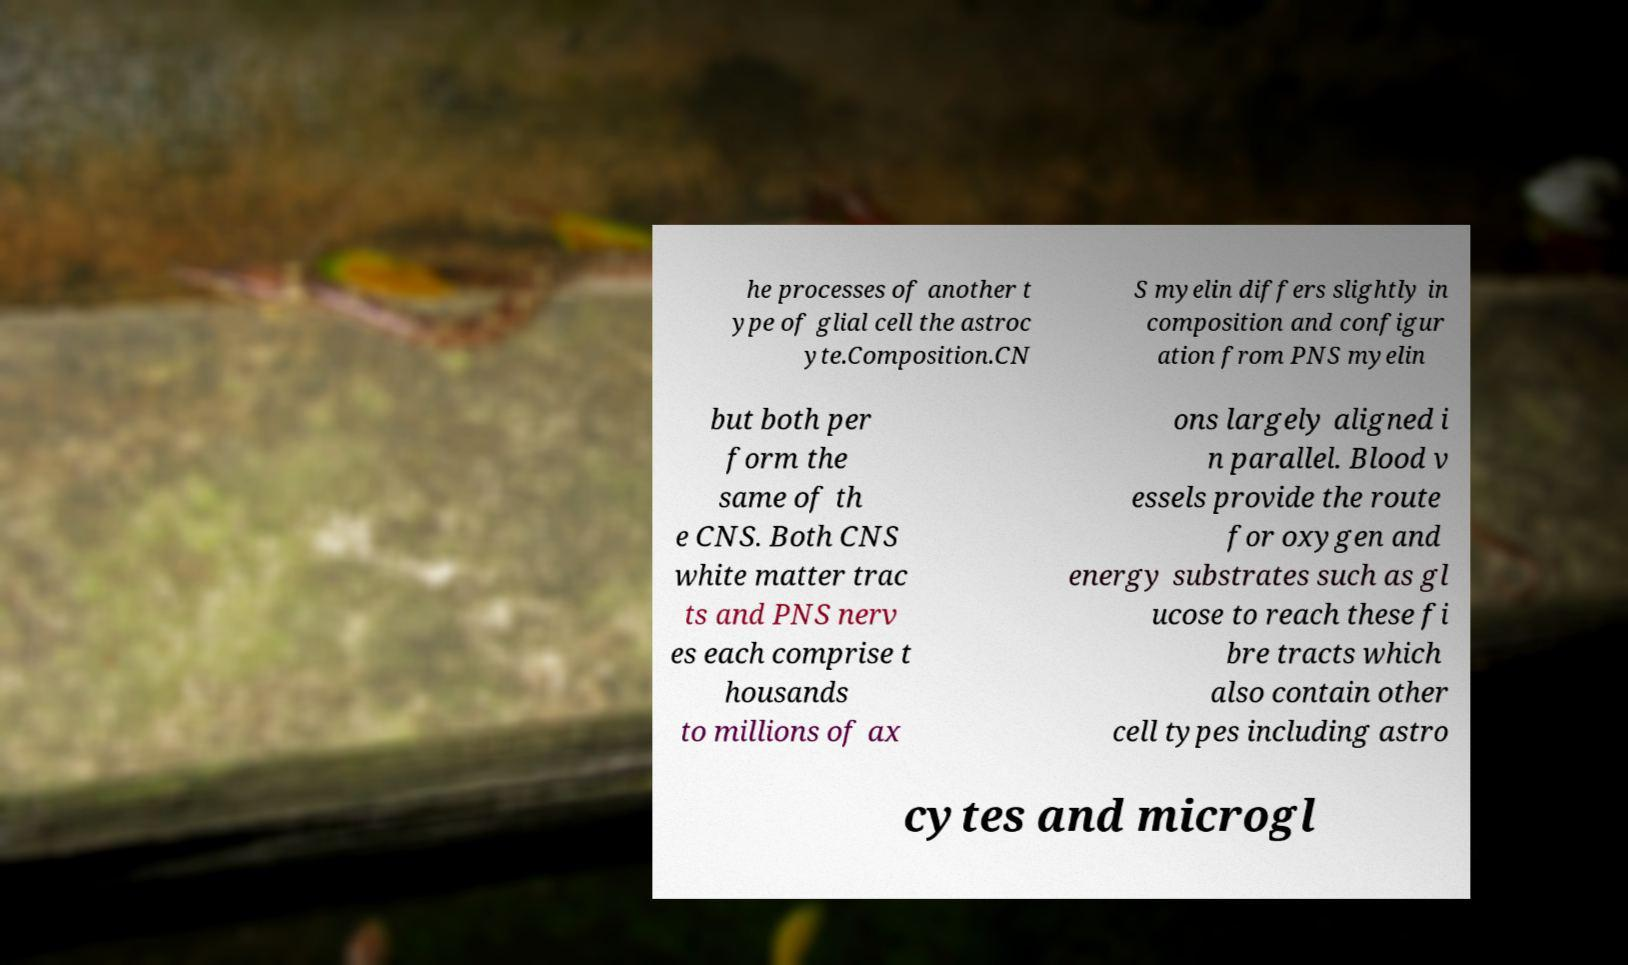There's text embedded in this image that I need extracted. Can you transcribe it verbatim? he processes of another t ype of glial cell the astroc yte.Composition.CN S myelin differs slightly in composition and configur ation from PNS myelin but both per form the same of th e CNS. Both CNS white matter trac ts and PNS nerv es each comprise t housands to millions of ax ons largely aligned i n parallel. Blood v essels provide the route for oxygen and energy substrates such as gl ucose to reach these fi bre tracts which also contain other cell types including astro cytes and microgl 